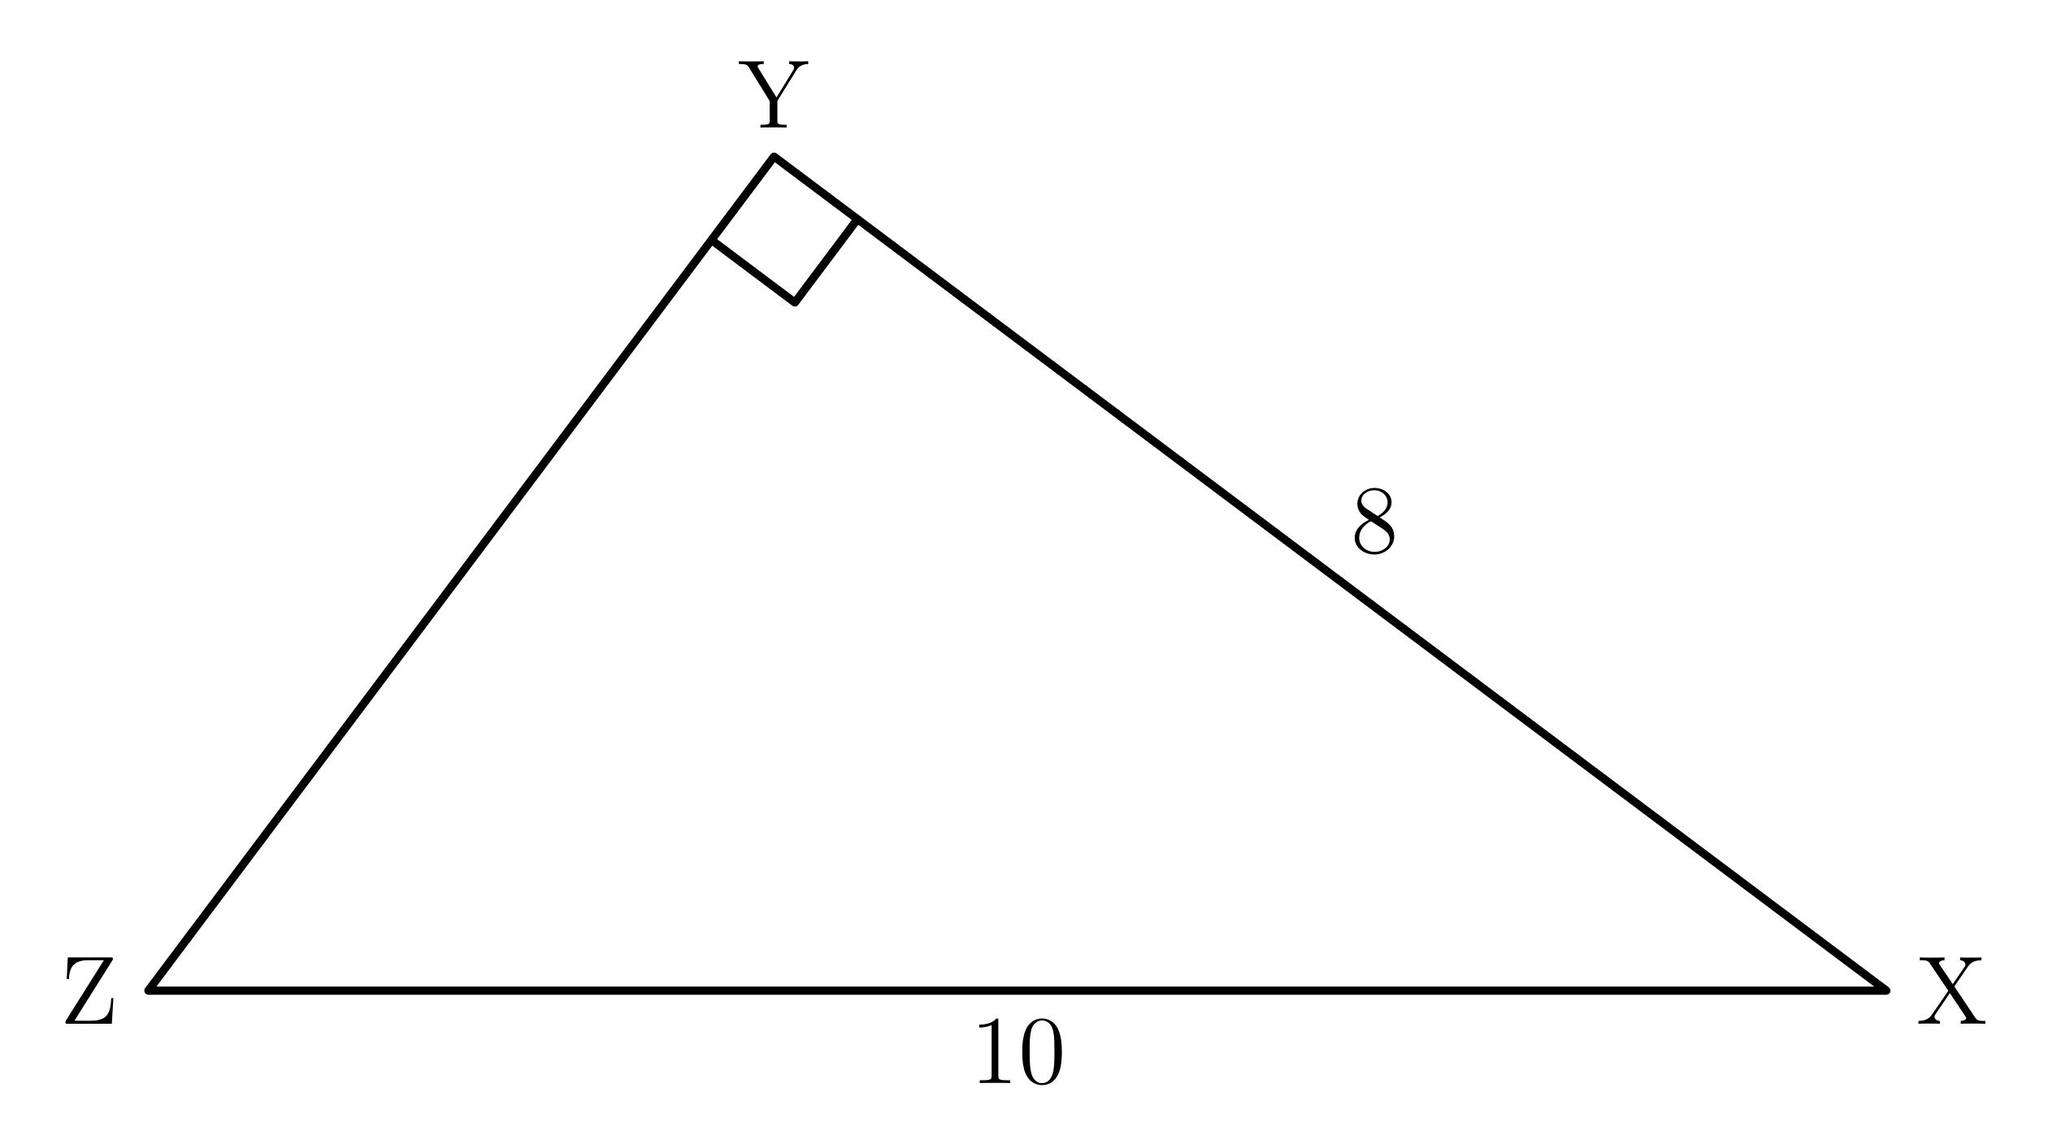What is the area of triangle XYZ? The area of a triangle is calculated as 1/2 times the base times the height. In the right triangle XYZ, where side XZ is the height, and side XY is the base, the area would be 1/2 times 10 times 8, which equals 40 square units. 